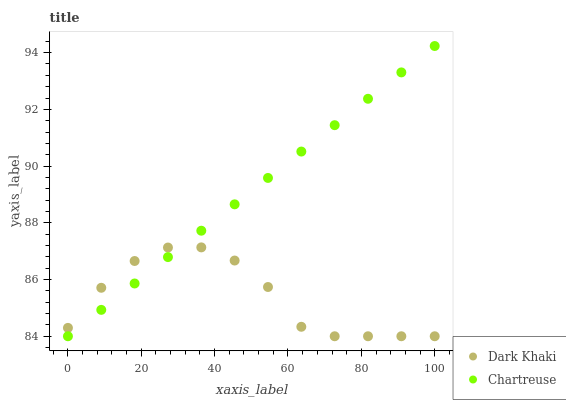Does Dark Khaki have the minimum area under the curve?
Answer yes or no. Yes. Does Chartreuse have the maximum area under the curve?
Answer yes or no. Yes. Does Chartreuse have the minimum area under the curve?
Answer yes or no. No. Is Chartreuse the smoothest?
Answer yes or no. Yes. Is Dark Khaki the roughest?
Answer yes or no. Yes. Is Chartreuse the roughest?
Answer yes or no. No. Does Dark Khaki have the lowest value?
Answer yes or no. Yes. Does Chartreuse have the highest value?
Answer yes or no. Yes. Does Dark Khaki intersect Chartreuse?
Answer yes or no. Yes. Is Dark Khaki less than Chartreuse?
Answer yes or no. No. Is Dark Khaki greater than Chartreuse?
Answer yes or no. No. 